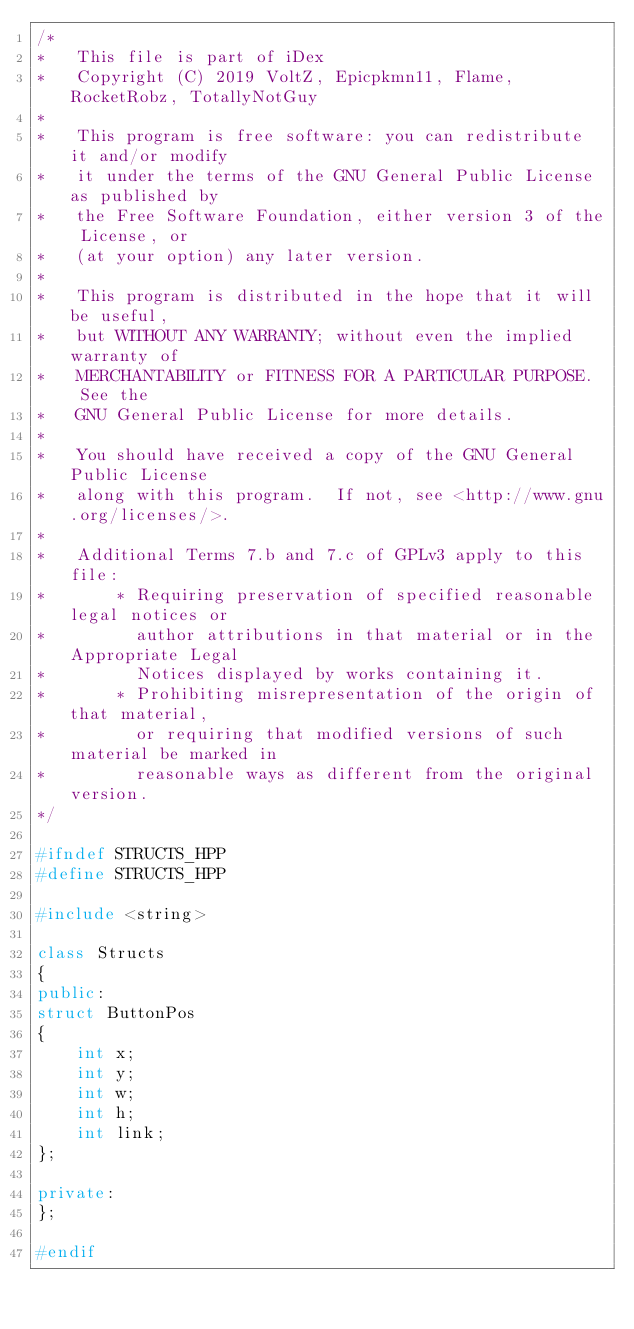<code> <loc_0><loc_0><loc_500><loc_500><_C++_>/*
*   This file is part of iDex
*   Copyright (C) 2019 VoltZ, Epicpkmn11, Flame, RocketRobz, TotallyNotGuy
*
*   This program is free software: you can redistribute it and/or modify
*   it under the terms of the GNU General Public License as published by
*   the Free Software Foundation, either version 3 of the License, or
*   (at your option) any later version.
*
*   This program is distributed in the hope that it will be useful,
*   but WITHOUT ANY WARRANTY; without even the implied warranty of
*   MERCHANTABILITY or FITNESS FOR A PARTICULAR PURPOSE.  See the
*   GNU General Public License for more details.
*
*   You should have received a copy of the GNU General Public License
*   along with this program.  If not, see <http://www.gnu.org/licenses/>.
*
*   Additional Terms 7.b and 7.c of GPLv3 apply to this file:
*       * Requiring preservation of specified reasonable legal notices or
*         author attributions in that material or in the Appropriate Legal
*         Notices displayed by works containing it.
*       * Prohibiting misrepresentation of the origin of that material,
*         or requiring that modified versions of such material be marked in
*         reasonable ways as different from the original version.
*/

#ifndef STRUCTS_HPP
#define STRUCTS_HPP

#include <string>

class Structs 
{
public:
struct ButtonPos
{
    int x;
    int y;
    int w;
    int h;
	int link;
};

private:
};

#endif</code> 